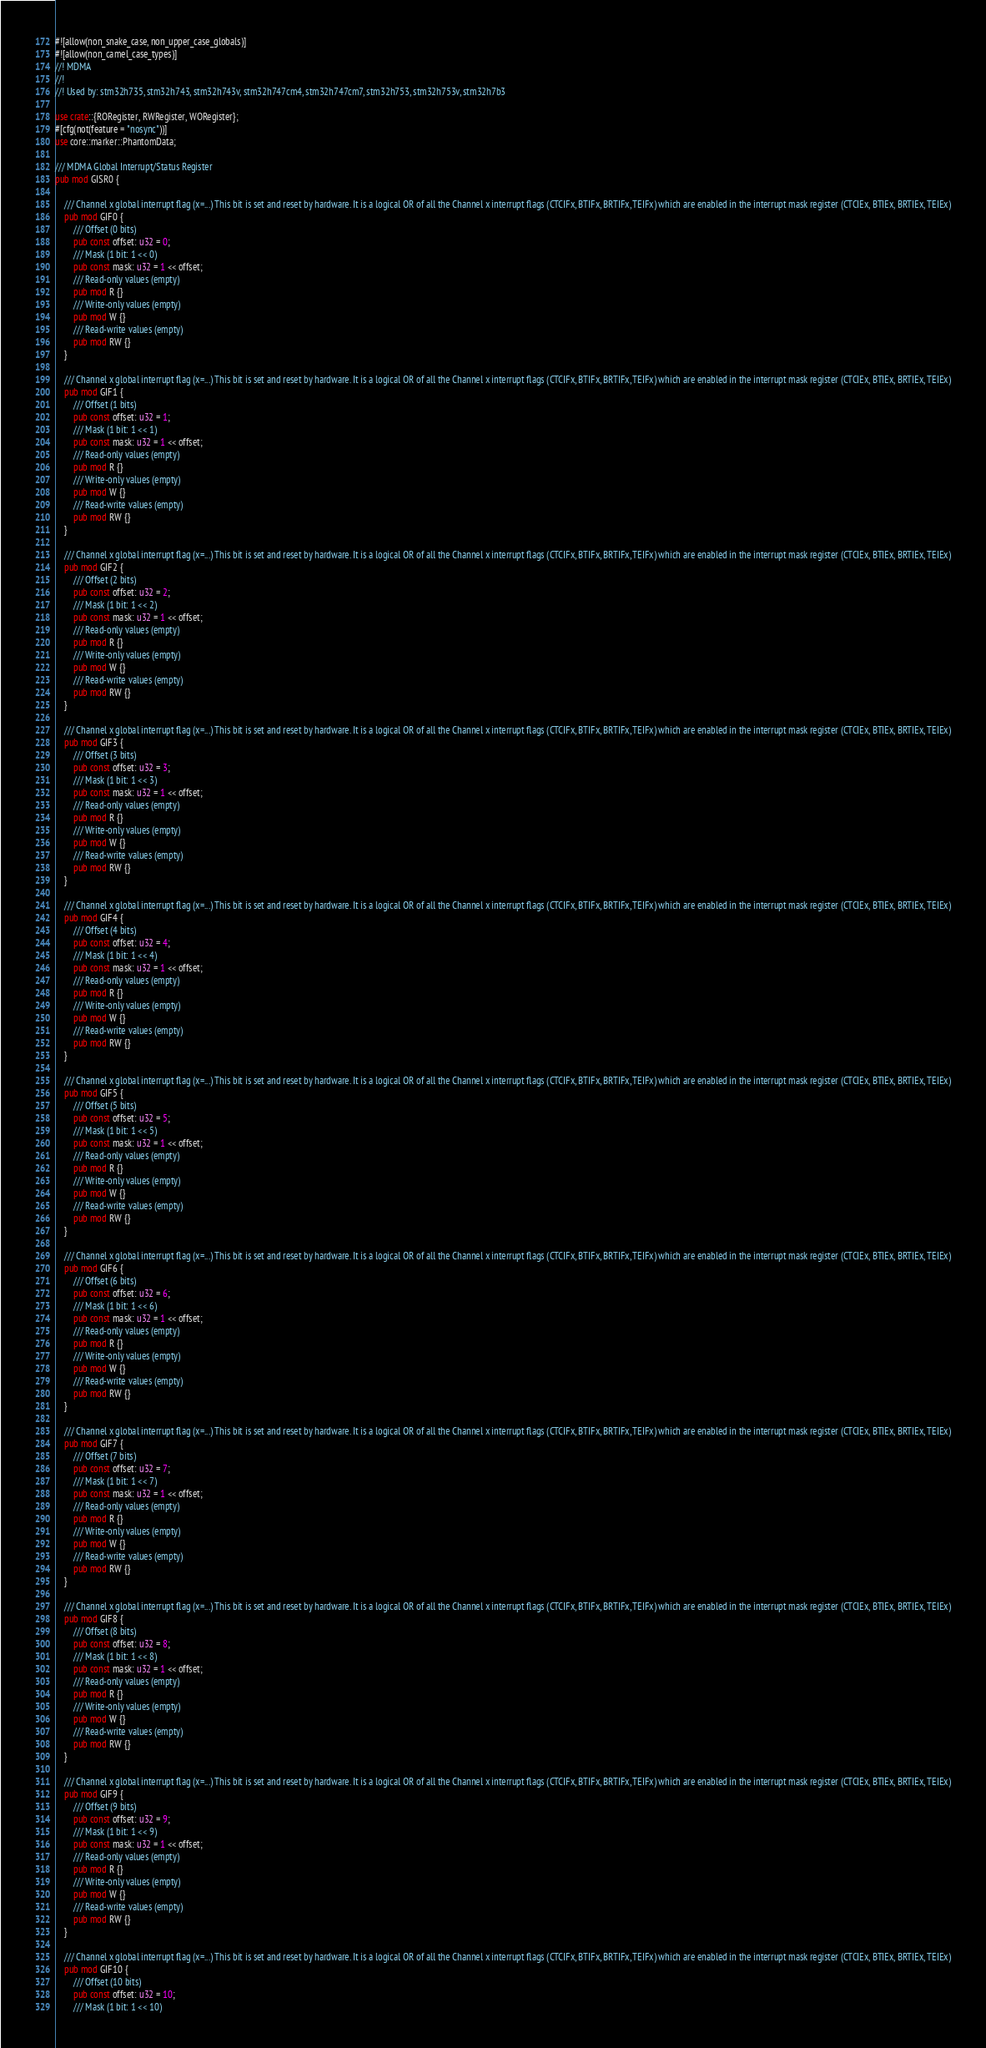<code> <loc_0><loc_0><loc_500><loc_500><_Rust_>#![allow(non_snake_case, non_upper_case_globals)]
#![allow(non_camel_case_types)]
//! MDMA
//!
//! Used by: stm32h735, stm32h743, stm32h743v, stm32h747cm4, stm32h747cm7, stm32h753, stm32h753v, stm32h7b3

use crate::{RORegister, RWRegister, WORegister};
#[cfg(not(feature = "nosync"))]
use core::marker::PhantomData;

/// MDMA Global Interrupt/Status Register
pub mod GISR0 {

    /// Channel x global interrupt flag (x=...) This bit is set and reset by hardware. It is a logical OR of all the Channel x interrupt flags (CTCIFx, BTIFx, BRTIFx, TEIFx) which are enabled in the interrupt mask register (CTCIEx, BTIEx, BRTIEx, TEIEx)
    pub mod GIF0 {
        /// Offset (0 bits)
        pub const offset: u32 = 0;
        /// Mask (1 bit: 1 << 0)
        pub const mask: u32 = 1 << offset;
        /// Read-only values (empty)
        pub mod R {}
        /// Write-only values (empty)
        pub mod W {}
        /// Read-write values (empty)
        pub mod RW {}
    }

    /// Channel x global interrupt flag (x=...) This bit is set and reset by hardware. It is a logical OR of all the Channel x interrupt flags (CTCIFx, BTIFx, BRTIFx, TEIFx) which are enabled in the interrupt mask register (CTCIEx, BTIEx, BRTIEx, TEIEx)
    pub mod GIF1 {
        /// Offset (1 bits)
        pub const offset: u32 = 1;
        /// Mask (1 bit: 1 << 1)
        pub const mask: u32 = 1 << offset;
        /// Read-only values (empty)
        pub mod R {}
        /// Write-only values (empty)
        pub mod W {}
        /// Read-write values (empty)
        pub mod RW {}
    }

    /// Channel x global interrupt flag (x=...) This bit is set and reset by hardware. It is a logical OR of all the Channel x interrupt flags (CTCIFx, BTIFx, BRTIFx, TEIFx) which are enabled in the interrupt mask register (CTCIEx, BTIEx, BRTIEx, TEIEx)
    pub mod GIF2 {
        /// Offset (2 bits)
        pub const offset: u32 = 2;
        /// Mask (1 bit: 1 << 2)
        pub const mask: u32 = 1 << offset;
        /// Read-only values (empty)
        pub mod R {}
        /// Write-only values (empty)
        pub mod W {}
        /// Read-write values (empty)
        pub mod RW {}
    }

    /// Channel x global interrupt flag (x=...) This bit is set and reset by hardware. It is a logical OR of all the Channel x interrupt flags (CTCIFx, BTIFx, BRTIFx, TEIFx) which are enabled in the interrupt mask register (CTCIEx, BTIEx, BRTIEx, TEIEx)
    pub mod GIF3 {
        /// Offset (3 bits)
        pub const offset: u32 = 3;
        /// Mask (1 bit: 1 << 3)
        pub const mask: u32 = 1 << offset;
        /// Read-only values (empty)
        pub mod R {}
        /// Write-only values (empty)
        pub mod W {}
        /// Read-write values (empty)
        pub mod RW {}
    }

    /// Channel x global interrupt flag (x=...) This bit is set and reset by hardware. It is a logical OR of all the Channel x interrupt flags (CTCIFx, BTIFx, BRTIFx, TEIFx) which are enabled in the interrupt mask register (CTCIEx, BTIEx, BRTIEx, TEIEx)
    pub mod GIF4 {
        /// Offset (4 bits)
        pub const offset: u32 = 4;
        /// Mask (1 bit: 1 << 4)
        pub const mask: u32 = 1 << offset;
        /// Read-only values (empty)
        pub mod R {}
        /// Write-only values (empty)
        pub mod W {}
        /// Read-write values (empty)
        pub mod RW {}
    }

    /// Channel x global interrupt flag (x=...) This bit is set and reset by hardware. It is a logical OR of all the Channel x interrupt flags (CTCIFx, BTIFx, BRTIFx, TEIFx) which are enabled in the interrupt mask register (CTCIEx, BTIEx, BRTIEx, TEIEx)
    pub mod GIF5 {
        /// Offset (5 bits)
        pub const offset: u32 = 5;
        /// Mask (1 bit: 1 << 5)
        pub const mask: u32 = 1 << offset;
        /// Read-only values (empty)
        pub mod R {}
        /// Write-only values (empty)
        pub mod W {}
        /// Read-write values (empty)
        pub mod RW {}
    }

    /// Channel x global interrupt flag (x=...) This bit is set and reset by hardware. It is a logical OR of all the Channel x interrupt flags (CTCIFx, BTIFx, BRTIFx, TEIFx) which are enabled in the interrupt mask register (CTCIEx, BTIEx, BRTIEx, TEIEx)
    pub mod GIF6 {
        /// Offset (6 bits)
        pub const offset: u32 = 6;
        /// Mask (1 bit: 1 << 6)
        pub const mask: u32 = 1 << offset;
        /// Read-only values (empty)
        pub mod R {}
        /// Write-only values (empty)
        pub mod W {}
        /// Read-write values (empty)
        pub mod RW {}
    }

    /// Channel x global interrupt flag (x=...) This bit is set and reset by hardware. It is a logical OR of all the Channel x interrupt flags (CTCIFx, BTIFx, BRTIFx, TEIFx) which are enabled in the interrupt mask register (CTCIEx, BTIEx, BRTIEx, TEIEx)
    pub mod GIF7 {
        /// Offset (7 bits)
        pub const offset: u32 = 7;
        /// Mask (1 bit: 1 << 7)
        pub const mask: u32 = 1 << offset;
        /// Read-only values (empty)
        pub mod R {}
        /// Write-only values (empty)
        pub mod W {}
        /// Read-write values (empty)
        pub mod RW {}
    }

    /// Channel x global interrupt flag (x=...) This bit is set and reset by hardware. It is a logical OR of all the Channel x interrupt flags (CTCIFx, BTIFx, BRTIFx, TEIFx) which are enabled in the interrupt mask register (CTCIEx, BTIEx, BRTIEx, TEIEx)
    pub mod GIF8 {
        /// Offset (8 bits)
        pub const offset: u32 = 8;
        /// Mask (1 bit: 1 << 8)
        pub const mask: u32 = 1 << offset;
        /// Read-only values (empty)
        pub mod R {}
        /// Write-only values (empty)
        pub mod W {}
        /// Read-write values (empty)
        pub mod RW {}
    }

    /// Channel x global interrupt flag (x=...) This bit is set and reset by hardware. It is a logical OR of all the Channel x interrupt flags (CTCIFx, BTIFx, BRTIFx, TEIFx) which are enabled in the interrupt mask register (CTCIEx, BTIEx, BRTIEx, TEIEx)
    pub mod GIF9 {
        /// Offset (9 bits)
        pub const offset: u32 = 9;
        /// Mask (1 bit: 1 << 9)
        pub const mask: u32 = 1 << offset;
        /// Read-only values (empty)
        pub mod R {}
        /// Write-only values (empty)
        pub mod W {}
        /// Read-write values (empty)
        pub mod RW {}
    }

    /// Channel x global interrupt flag (x=...) This bit is set and reset by hardware. It is a logical OR of all the Channel x interrupt flags (CTCIFx, BTIFx, BRTIFx, TEIFx) which are enabled in the interrupt mask register (CTCIEx, BTIEx, BRTIEx, TEIEx)
    pub mod GIF10 {
        /// Offset (10 bits)
        pub const offset: u32 = 10;
        /// Mask (1 bit: 1 << 10)</code> 